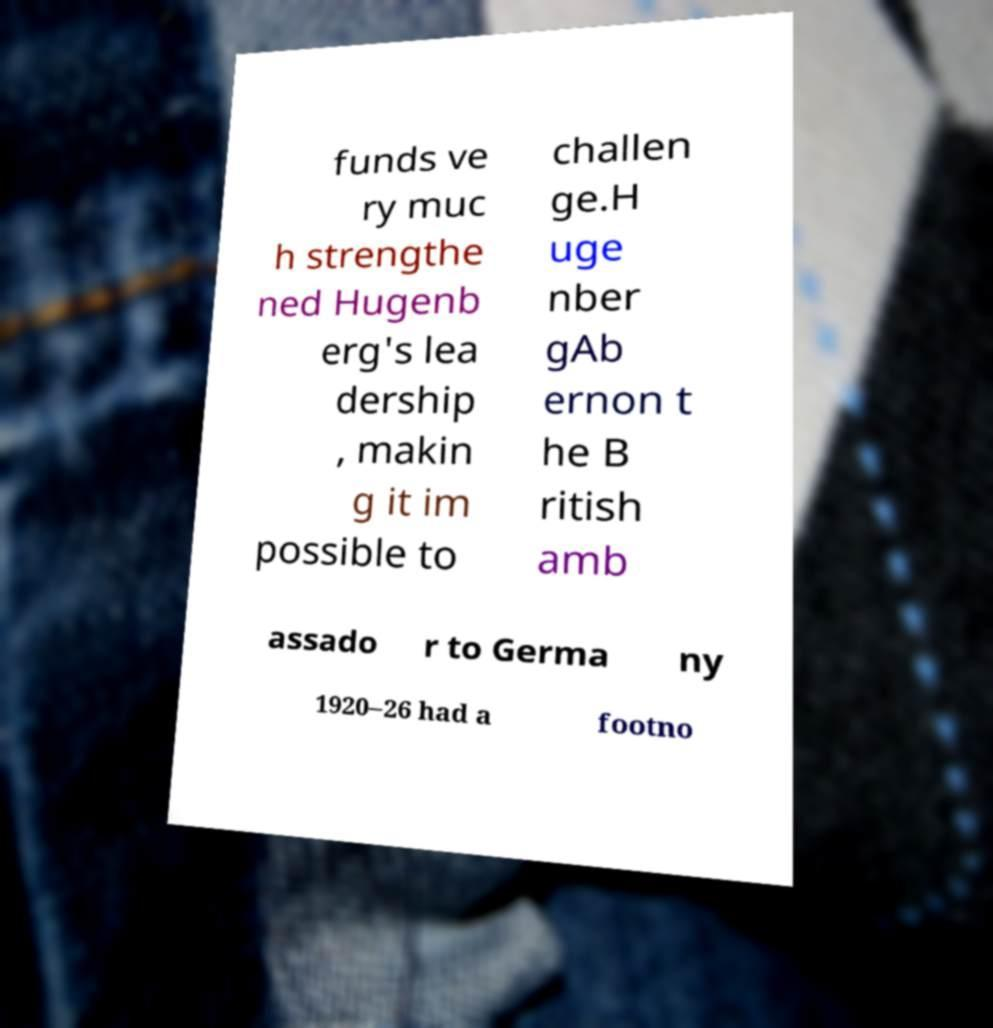There's text embedded in this image that I need extracted. Can you transcribe it verbatim? funds ve ry muc h strengthe ned Hugenb erg's lea dership , makin g it im possible to challen ge.H uge nber gAb ernon t he B ritish amb assado r to Germa ny 1920–26 had a footno 